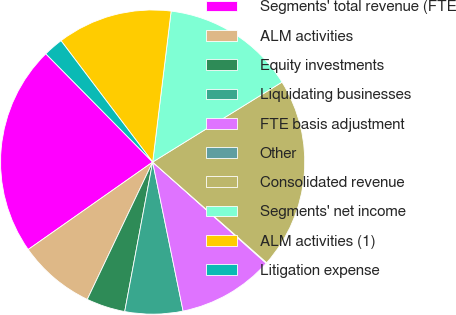<chart> <loc_0><loc_0><loc_500><loc_500><pie_chart><fcel>Segments' total revenue (FTE<fcel>ALM activities<fcel>Equity investments<fcel>Liquidating businesses<fcel>FTE basis adjustment<fcel>Other<fcel>Consolidated revenue<fcel>Segments' net income<fcel>ALM activities (1)<fcel>Litigation expense<nl><fcel>22.35%<fcel>8.18%<fcel>4.13%<fcel>6.15%<fcel>10.2%<fcel>0.08%<fcel>20.32%<fcel>14.25%<fcel>12.23%<fcel>2.1%<nl></chart> 